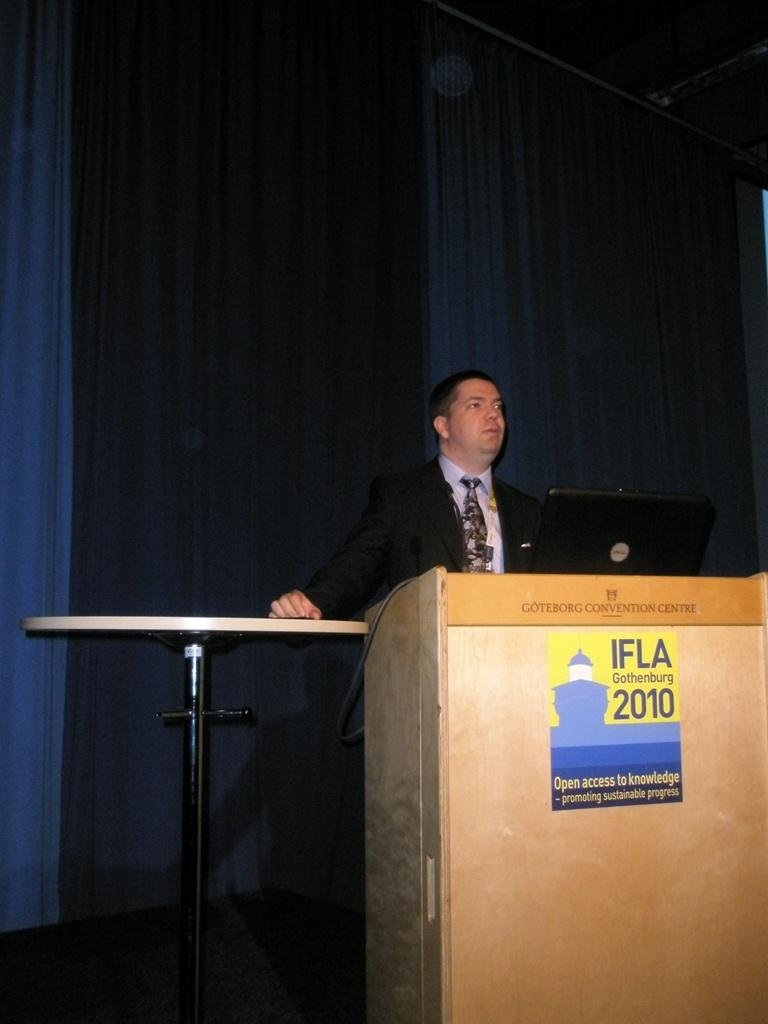What is the man at the podium doing in the image? The man is standing at the podium. What is in front of the man on the table? There is a laptop and a poster in front of the man on the table. What might the man be using to display information or communicate with the audience? The laptop and poster in front of the man might be used for displaying information or communicating with the audience. What can be seen in the background of the image? There are curtains in the background of the image. What type of fog can be seen in the image? There is no fog present in the image. What is the man writing on the poster in the image? The image does not show the man writing on the poster; it only shows the man standing at the podium with a laptop and a poster in front of him. 